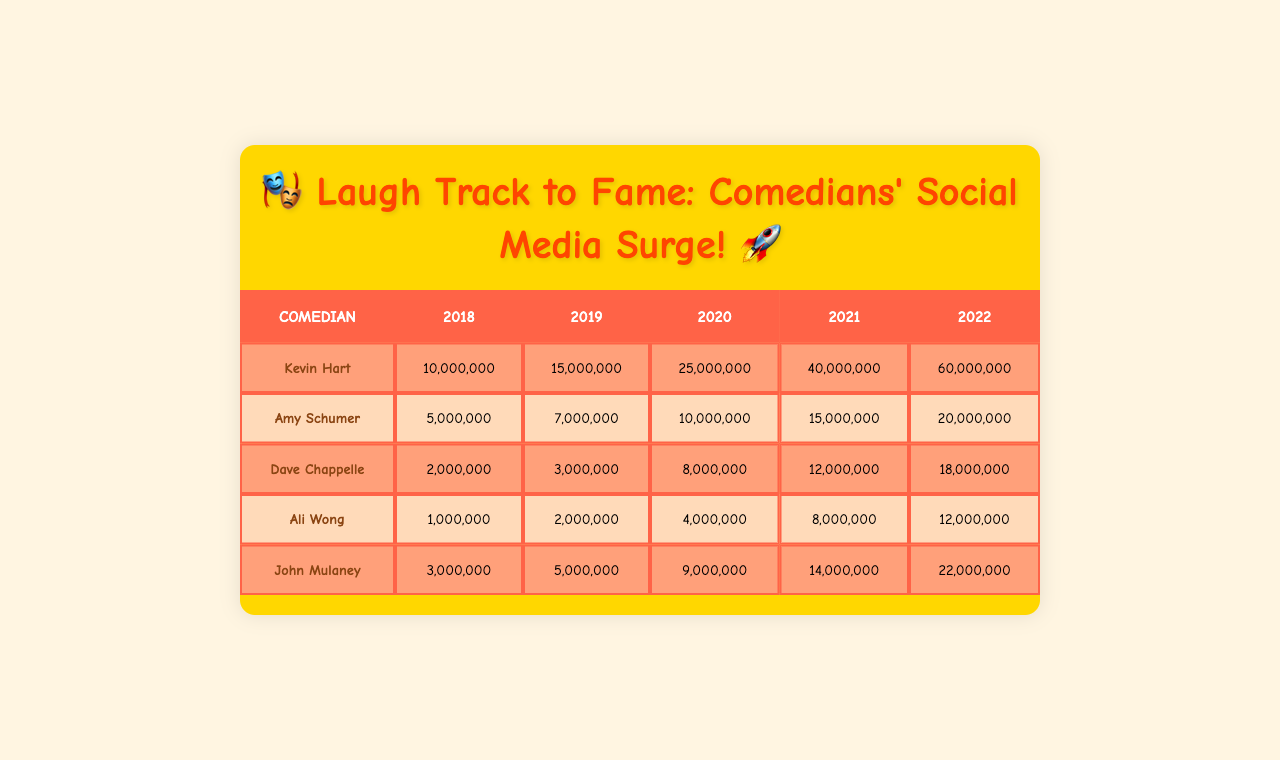What is the follower count for Kevin Hart in 2022? We look at the row for Kevin Hart in the table and find the value under the year 2022. The follower count is 60,000,000.
Answer: 60,000,000 What year did Ali Wong reach 8,000,000 followers? We check the row for Ali Wong and look at the follower counts across the years. The value 8,000,000 is in the year 2021.
Answer: 2021 Which comedian had the highest follower count in 2020? We compare the follower counts for all comedians in the year 2020. Kevin Hart had the highest count at 25,000,000.
Answer: Kevin Hart How many followers did John Mulaney gain from 2018 to 2022? We find the follower counts for John Mulaney in 2018 (3,000,000) and in 2022 (22,000,000), then we subtract: 22,000,000 - 3,000,000 = 19,000,000.
Answer: 19,000,000 What’s the average follower count for Dave Chappelle from 2018 to 2022? We take the follower counts for Dave Chappelle from 2018 to 2022: 2,000,000 + 3,000,000 + 8,000,000 + 12,000,000 + 18,000,000 = 43,000,000. There are 5 years, so we divide 43,000,000 by 5, giving us an average of 8,600,000.
Answer: 8,600,000 Did Amy Schumer have more than 10 million followers in 2019? We check Amy Schumer's follower count for 2019, which is 7,000,000, therefore she did not have more than 10 million.
Answer: No In which year did Ali Wong's followers double compared to 2018? Ali Wong had 1,000,000 followers in 2018. Doubling that gives us 2,000,000. Looking at the table, she reached 2,000,000 followers in 2019.
Answer: 2019 Which comedian had the smallest follower count in 2018? We check the follower counts for 2018 across all comedians. Ali Wong had the smallest count, with 1,000,000 followers.
Answer: Ali Wong What is the total follower count for all comedians in 2020? We sum the follower counts in 2020: 25,000,000 (Kevin Hart) + 10,000,000 (Amy Schumer) + 8,000,000 (Dave Chappelle) + 4,000,000 (Ali Wong) + 9,000,000 (John Mulaney) = 56,000,000.
Answer: 56,000,000 Which comedian showed the most consistent growth over the years? We visualize the growth of each comedian's follower count over the years. Kevin Hart significantly increased each year, from 10,000,000 in 2018 to 60,000,000 in 2022, making his growth consistent in terms of rate.
Answer: Kevin Hart 